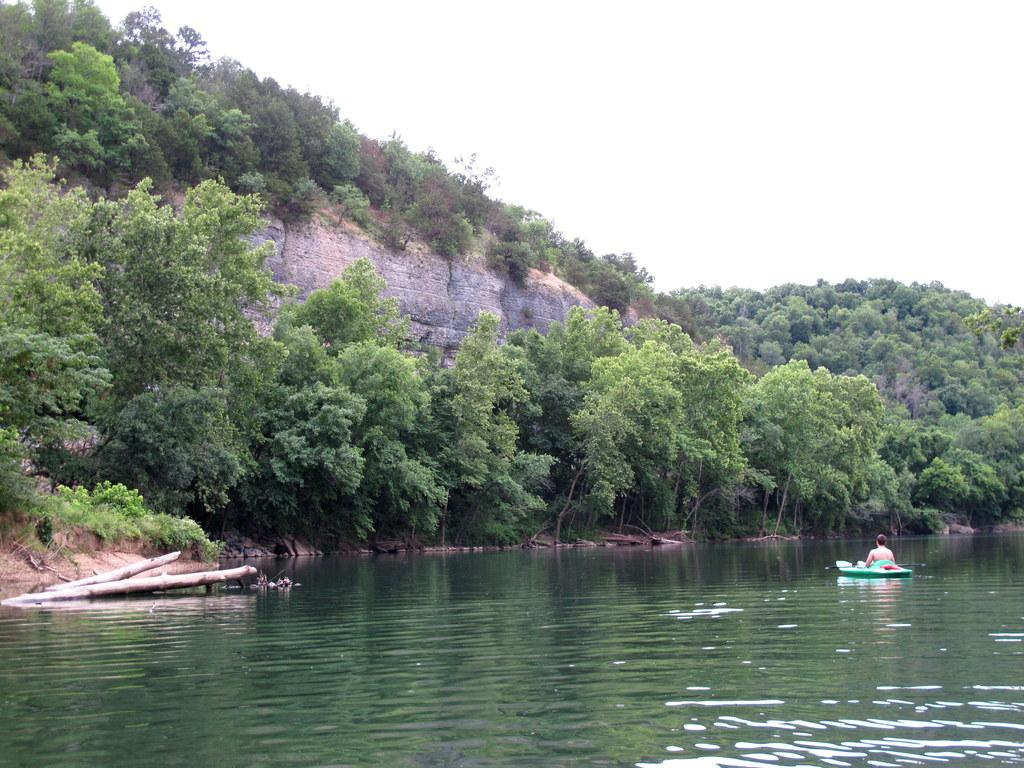What is the person in the image doing? The person is sitting on a boat in the image. What is the boat doing in the image? The person is sailing on the water in the boat. What can be seen in the background of the image? There are trees and the sky visible in the background of the image. Can you describe any other elements in the background of the image? There are other unspecified elements in the background of the image. What is the tendency of the stomach in the image? There is no stomach present in the image, so it is not possible to determine its tendency. 